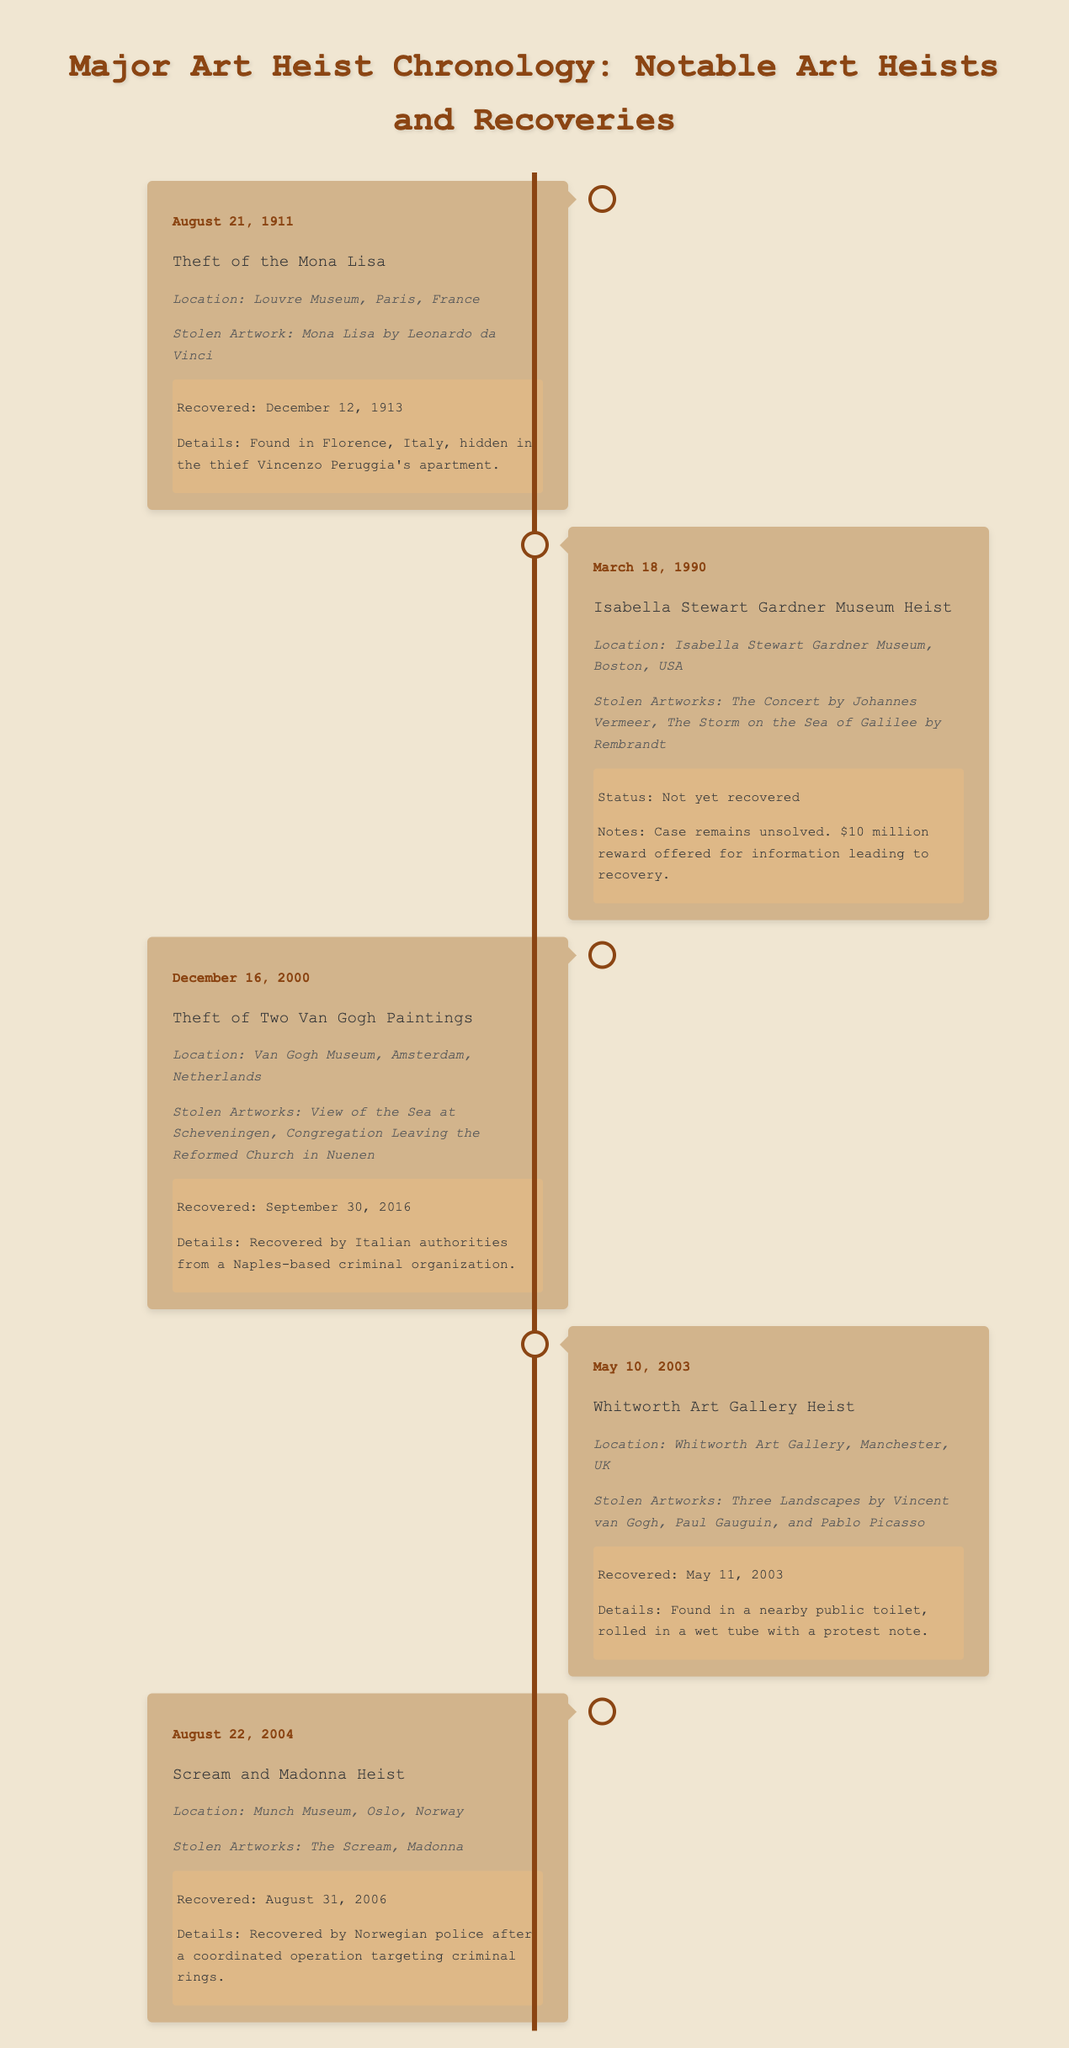What artwork was stolen on August 21, 1911? The document states that the stolen artwork was the "Mona Lisa" by Leonardo da Vinci.
Answer: Mona Lisa What is the status of the Isabella Stewart Gardner Museum heist? The document indicates that the status is "Not yet recovered."
Answer: Not yet recovered When were the Van Gogh paintings recovered? According to the timeline, the Van Gogh paintings were recovered on September 30, 2016.
Answer: September 30, 2016 Which museum was targeted during the theft of "The Scream" and "Madonna"? The document mentions that the Munch Museum in Oslo, Norway, was targeted.
Answer: Munch Museum How many artworks were stolen during the Whitworth Art Gallery heist? The document states that "Three Landscapes" were stolen, indicating three artworks.
Answer: Three What was the recovery method for the stolen artworks from the Whitworth Art Gallery? The document details that the artworks were found "in a nearby public toilet."
Answer: In a nearby public toilet Which artist is associated with the stolen artwork "The Storm on the Sea of Galilee"? The document mentions that the artwork was created by Rembrandt.
Answer: Rembrandt When did the theft of the two Van Gogh paintings occur? The timeline indicates that the theft occurred on December 16, 2000.
Answer: December 16, 2000 Where was the Mona Lisa recovered? The document specifies that the Mona Lisa was found in Florence, Italy.
Answer: Florence, Italy 